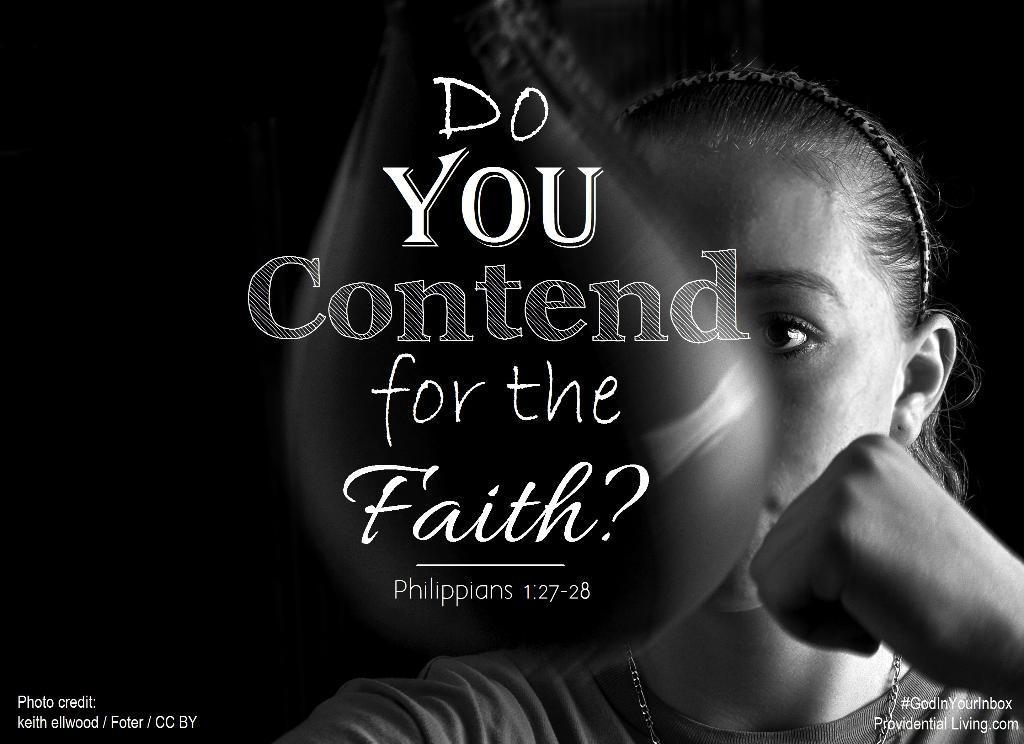In one or two sentences, can you explain what this image depicts? This is a black and white image. This is an edited image. There is a woman on the right side. There is something written in the middle. 